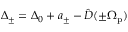<formula> <loc_0><loc_0><loc_500><loc_500>\Delta _ { \pm } = \Delta _ { 0 } + a _ { \pm } - \hat { D } ( \pm \Omega _ { p } )</formula> 